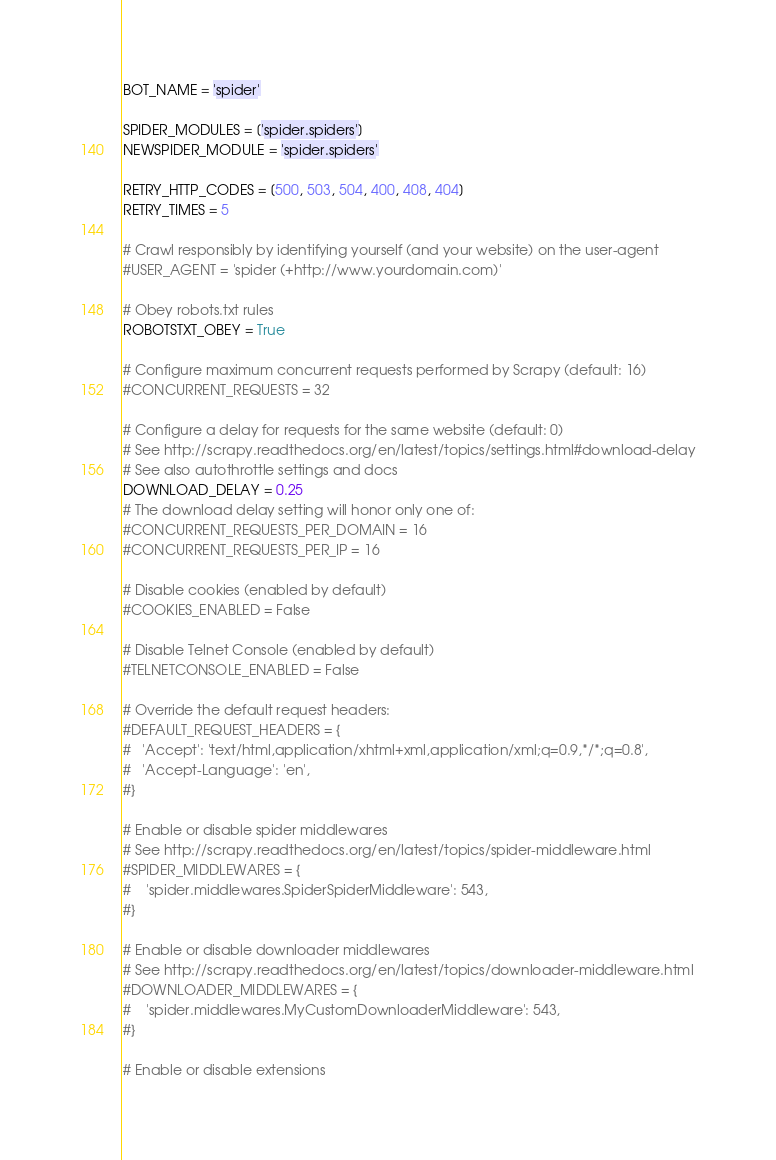<code> <loc_0><loc_0><loc_500><loc_500><_Python_>
BOT_NAME = 'spider'

SPIDER_MODULES = ['spider.spiders']
NEWSPIDER_MODULE = 'spider.spiders'

RETRY_HTTP_CODES = [500, 503, 504, 400, 408, 404]
RETRY_TIMES = 5

# Crawl responsibly by identifying yourself (and your website) on the user-agent
#USER_AGENT = 'spider (+http://www.yourdomain.com)'

# Obey robots.txt rules
ROBOTSTXT_OBEY = True

# Configure maximum concurrent requests performed by Scrapy (default: 16)
#CONCURRENT_REQUESTS = 32

# Configure a delay for requests for the same website (default: 0)
# See http://scrapy.readthedocs.org/en/latest/topics/settings.html#download-delay
# See also autothrottle settings and docs
DOWNLOAD_DELAY = 0.25
# The download delay setting will honor only one of:
#CONCURRENT_REQUESTS_PER_DOMAIN = 16
#CONCURRENT_REQUESTS_PER_IP = 16

# Disable cookies (enabled by default)
#COOKIES_ENABLED = False

# Disable Telnet Console (enabled by default)
#TELNETCONSOLE_ENABLED = False

# Override the default request headers:
#DEFAULT_REQUEST_HEADERS = {
#   'Accept': 'text/html,application/xhtml+xml,application/xml;q=0.9,*/*;q=0.8',
#   'Accept-Language': 'en',
#}

# Enable or disable spider middlewares
# See http://scrapy.readthedocs.org/en/latest/topics/spider-middleware.html
#SPIDER_MIDDLEWARES = {
#    'spider.middlewares.SpiderSpiderMiddleware': 543,
#}

# Enable or disable downloader middlewares
# See http://scrapy.readthedocs.org/en/latest/topics/downloader-middleware.html
#DOWNLOADER_MIDDLEWARES = {
#    'spider.middlewares.MyCustomDownloaderMiddleware': 543,
#}

# Enable or disable extensions</code> 